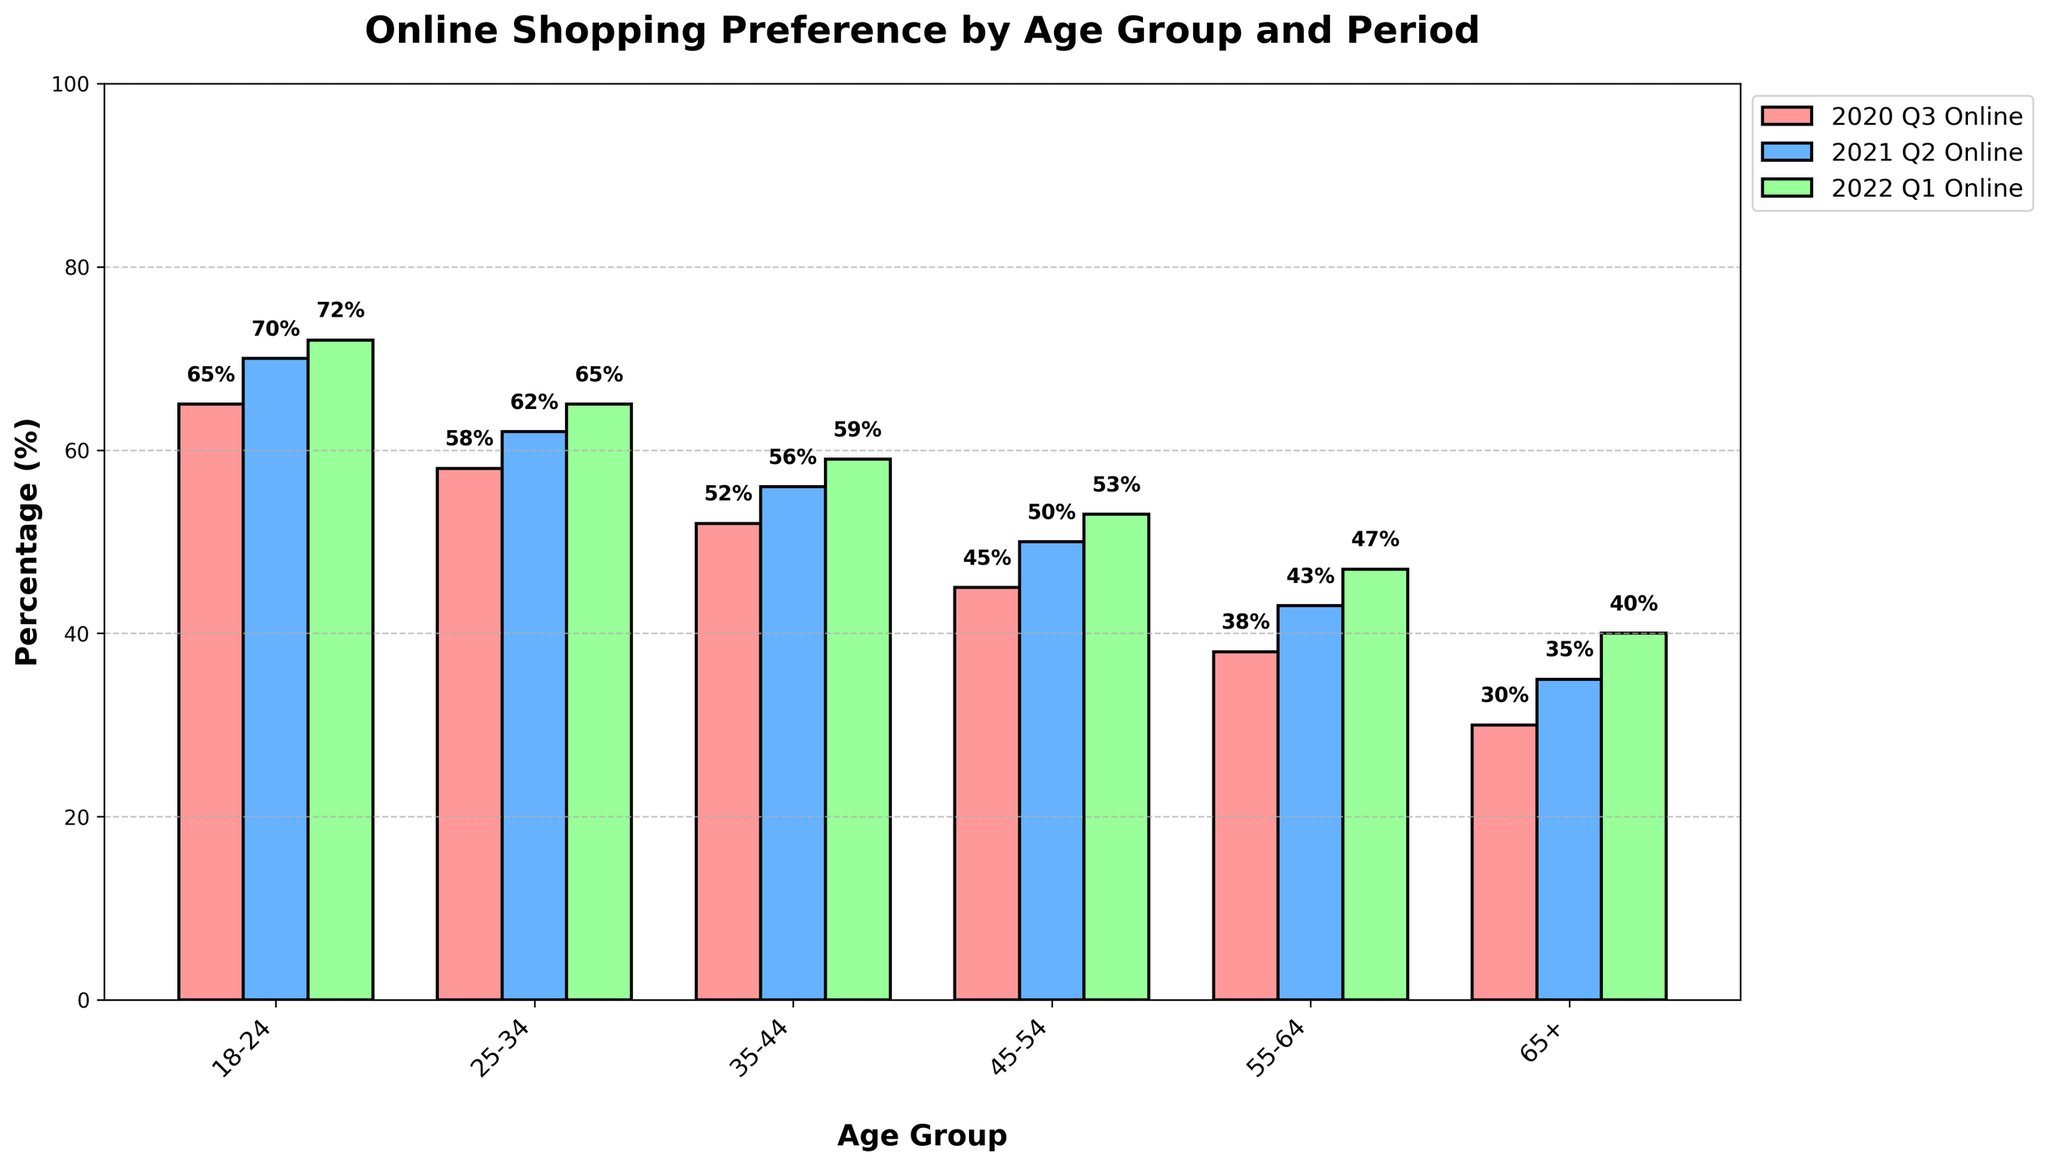What is the online shopping percentage for the age group 18-24 in 2022 Q1? Look for the bar corresponding to the age group 18-24 in 2022 Q1 and read the value at the top of the bar. The bar value is labeled with 72%.
Answer: 72% Which age group had the highest online shopping percentage in 2020 Q3? Compare the heights of the bars for all age groups in 2020 Q3. The highest bar corresponds to the age group 18-24, which is 65%.
Answer: 18-24 What is the difference in online shopping percentage between the age groups 35-44 and 55-64 in 2021 Q2? Identify the bars for 35-44 and 55-64 in 2021 Q2 and read their values: 56% and 43%. Subtract the smaller value from the larger one: 56% - 43% = 13%.
Answer: 13% What trend can be observed in the online shopping percentage for the age group 45-54 from 2020 Q3 to 2022 Q1? Observe the height of the bars for 45-54 across 2020 Q3, 2021 Q2, and 2022 Q1. The values increase from 45% to 50% to 53%, respectively.
Answer: Increasing trend How did the online shopping preference change for the age group 25-34 from 2020 Q3 to 2022 Q1? Locate the bars for the 25-34 age group in the periods 2020 Q3 and 2022 Q1. The values changed from 58% to 65%. The increase can be calculated as 65% - 58% = 7%.
Answer: Increased by 7% Which age group consistently prefers online shopping more than in-store shopping across all periods? Check each period for each age group's online and in-store shopping percentages. If the online shopping percentage is consistently higher in all periods, that age group prefers online shopping more. The 18-24 age group always has online shopping percentages higher than in-store.
Answer: 18-24 What is the average online shopping percentage for the age group 55-64 across all periods? Calculate the sum of the online shopping percentages for the 55-64 age group across all periods: 38% (2020 Q3) + 43% (2021 Q2) + 47% (2022 Q1) = 128%. Divide this sum by the number of periods: 128% / 3 = ~42.7%.
Answer: 42.7% How does the change in online shopping percentage from 2020 Q3 to 2022 Q1 for the age group 65+ compare to that for the age group 35-44? Determine the changes for each age group:
- For 65+: 40% (2022 Q1) - 30% (2020 Q3) = 10% increase.
- For 35-44: 59% (2022 Q1) - 52% (2020 Q3) = 7% increase.
Compare the increases, with 65+ having a higher increase than 35-44.
Answer: 65+ increased by 10%, 35-44 increased by 7% 